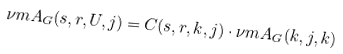<formula> <loc_0><loc_0><loc_500><loc_500>\nu m { A _ { G } ( s , r , U , j ) } = C ( s , r , k , j ) \cdot \nu m { A _ { G } ( k , j , k ) }</formula> 